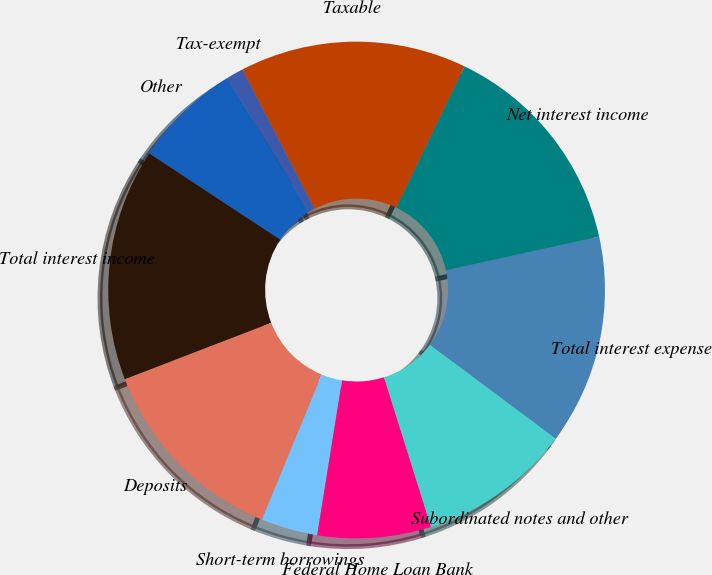<chart> <loc_0><loc_0><loc_500><loc_500><pie_chart><fcel>Taxable<fcel>Tax-exempt<fcel>Other<fcel>Total interest income<fcel>Deposits<fcel>Short-term borrowings<fcel>Federal Home Loan Bank<fcel>Subordinated notes and other<fcel>Total interest expense<fcel>Net interest income<nl><fcel>14.76%<fcel>1.11%<fcel>7.01%<fcel>15.13%<fcel>12.92%<fcel>3.69%<fcel>7.38%<fcel>9.96%<fcel>13.65%<fcel>14.39%<nl></chart> 